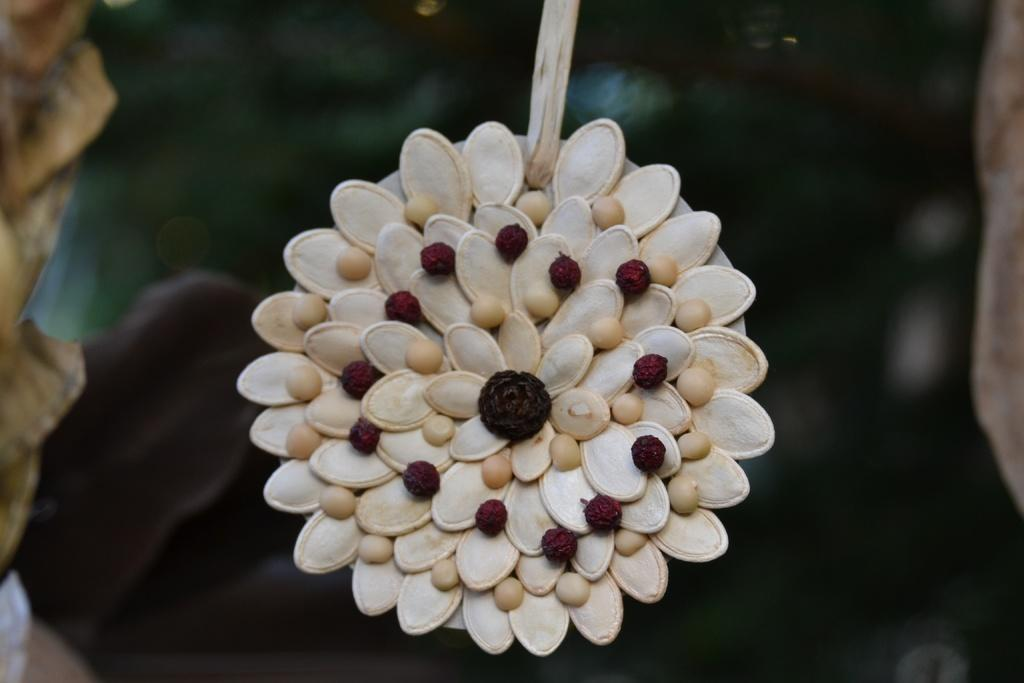What is the main subject of the image? The main subject of the image is seeds arranged in a flower shape. Can you describe the background of the image? The background of the image is blurred. What type of error can be seen on the wall in the image? There is no wall or error present in the image; it features seeds arranged in a flower shape with a blurred background. Can you describe the woman in the image? There is no woman present in the image; it features seeds arranged in a flower shape with a blurred background. 